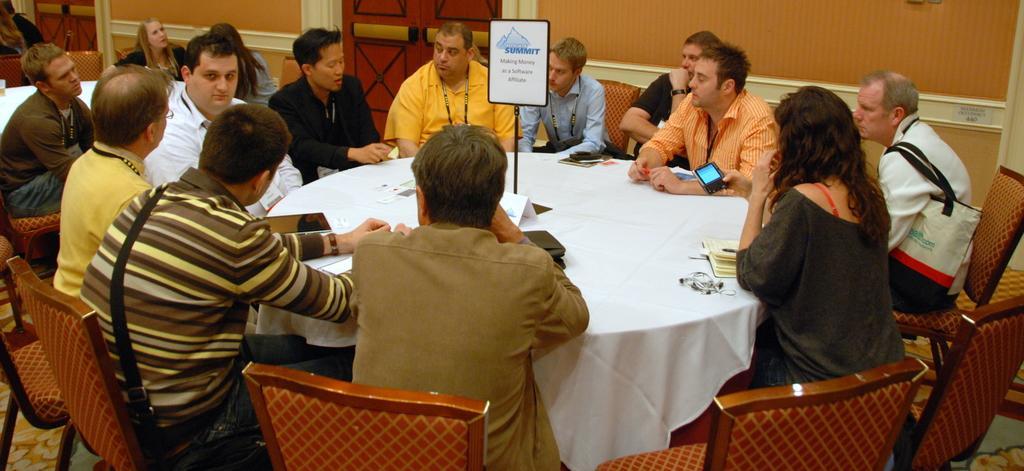Could you give a brief overview of what you see in this image? Here in this picture we can see many people sitting Around the table a white cloth is on the table. We can see a lady and 10 men are sitting around the table. Behind them there is a door. In the middle of that table there is stand we can see a summit on it. Behind this people there is an another table. To that table there are two ladies sitting and talking. 